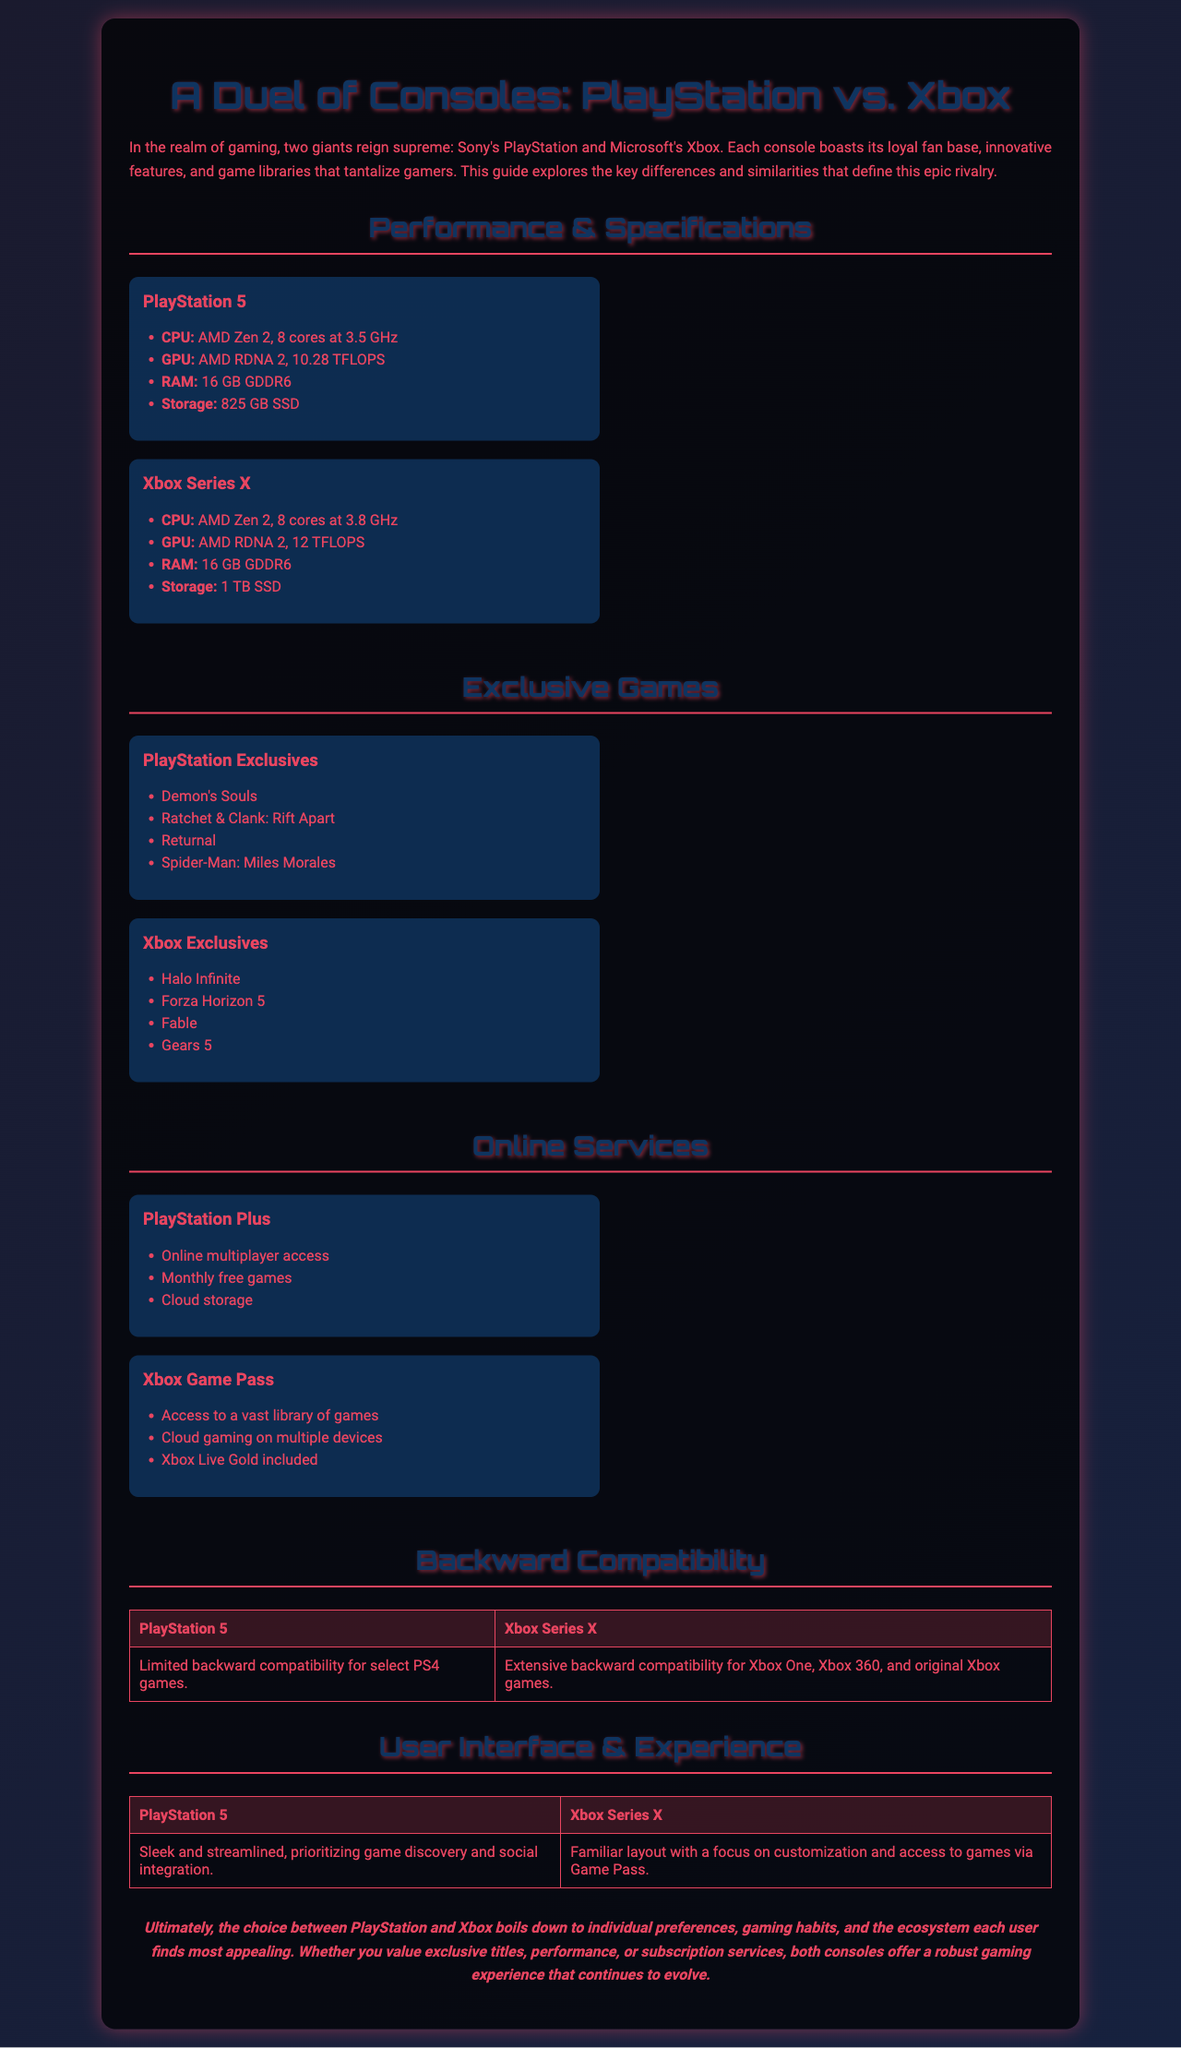what is the CPU of PlayStation 5? The CPU of PlayStation 5 is AMD Zen 2, 8 cores at 3.5 GHz.
Answer: AMD Zen 2, 8 cores at 3.5 GHz how many exclusive games are listed for Xbox? The document lists four exclusive games for Xbox in the 'Exclusive Games' section.
Answer: 4 what is the total storage capacity of Xbox Series X? The document states that the storage capacity of Xbox Series X is 1 TB SSD.
Answer: 1 TB SSD which console has better backward compatibility? The document states that Xbox Series X has extensive backward compatibility.
Answer: Xbox Series X what is a key feature of PlayStation Plus? One of the features of PlayStation Plus is online multiplayer access.
Answer: Online multiplayer access which GPU has a higher performance measured in TFLOPS? The Xbox Series X has a higher GPU performance of 12 TFLOPS compared to PlayStation 5’s 10.28 TFLOPS.
Answer: Xbox Series X what type of content does Xbox Game Pass offer? Xbox Game Pass offers access to a vast library of games.
Answer: Access to a vast library of games how is the user interface of PlayStation 5 described? The user interface of PlayStation 5 is described as sleek and streamlined.
Answer: Sleek and streamlined what do both consoles prioritize in their gaming experience? Both consoles prioritize gaming habits and individual preferences in their gaming experience.
Answer: Gaming habits and individual preferences 